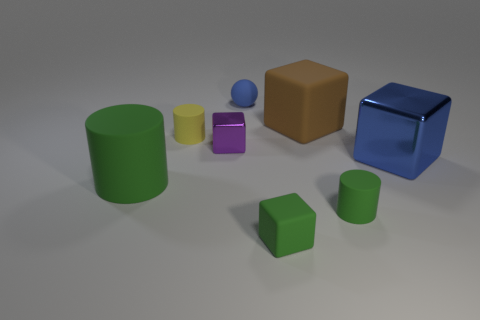Subtract 1 blocks. How many blocks are left? 3 Add 1 tiny green metallic cylinders. How many objects exist? 9 Subtract all cylinders. How many objects are left? 5 Subtract all tiny gray rubber blocks. Subtract all green rubber cubes. How many objects are left? 7 Add 5 green cubes. How many green cubes are left? 6 Add 5 big cyan rubber balls. How many big cyan rubber balls exist? 5 Subtract 1 yellow cylinders. How many objects are left? 7 